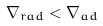<formula> <loc_0><loc_0><loc_500><loc_500>\nabla _ { r a d } < \nabla _ { a d }</formula> 